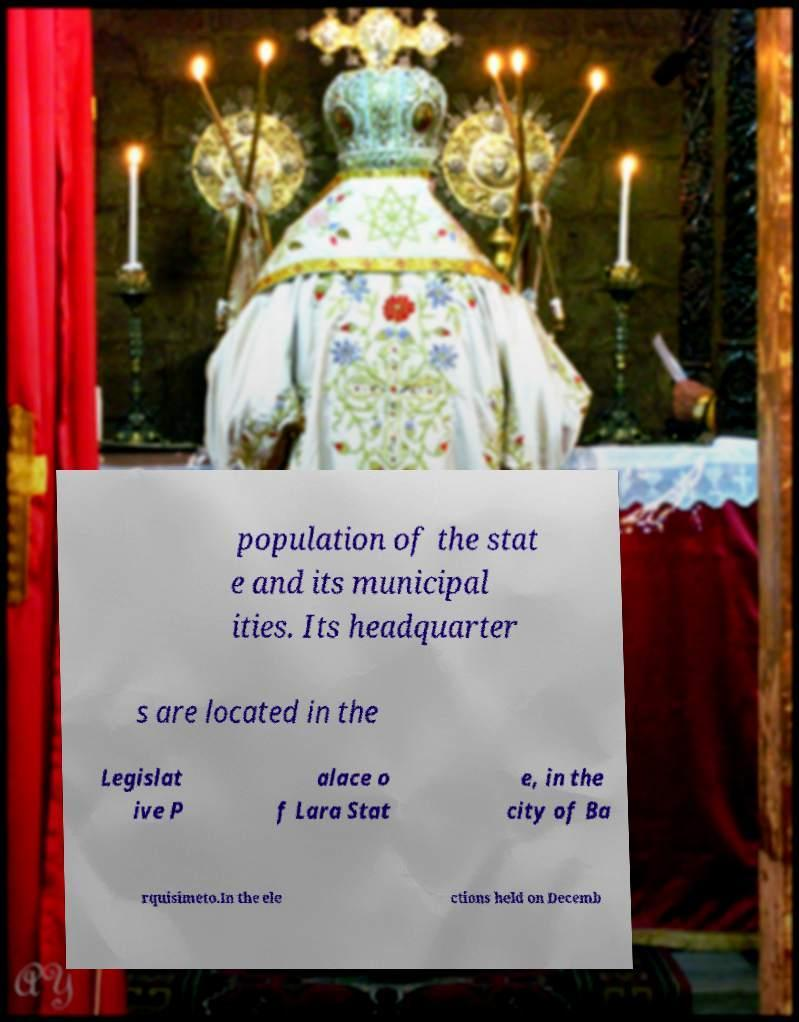Please read and relay the text visible in this image. What does it say? population of the stat e and its municipal ities. Its headquarter s are located in the Legislat ive P alace o f Lara Stat e, in the city of Ba rquisimeto.In the ele ctions held on Decemb 